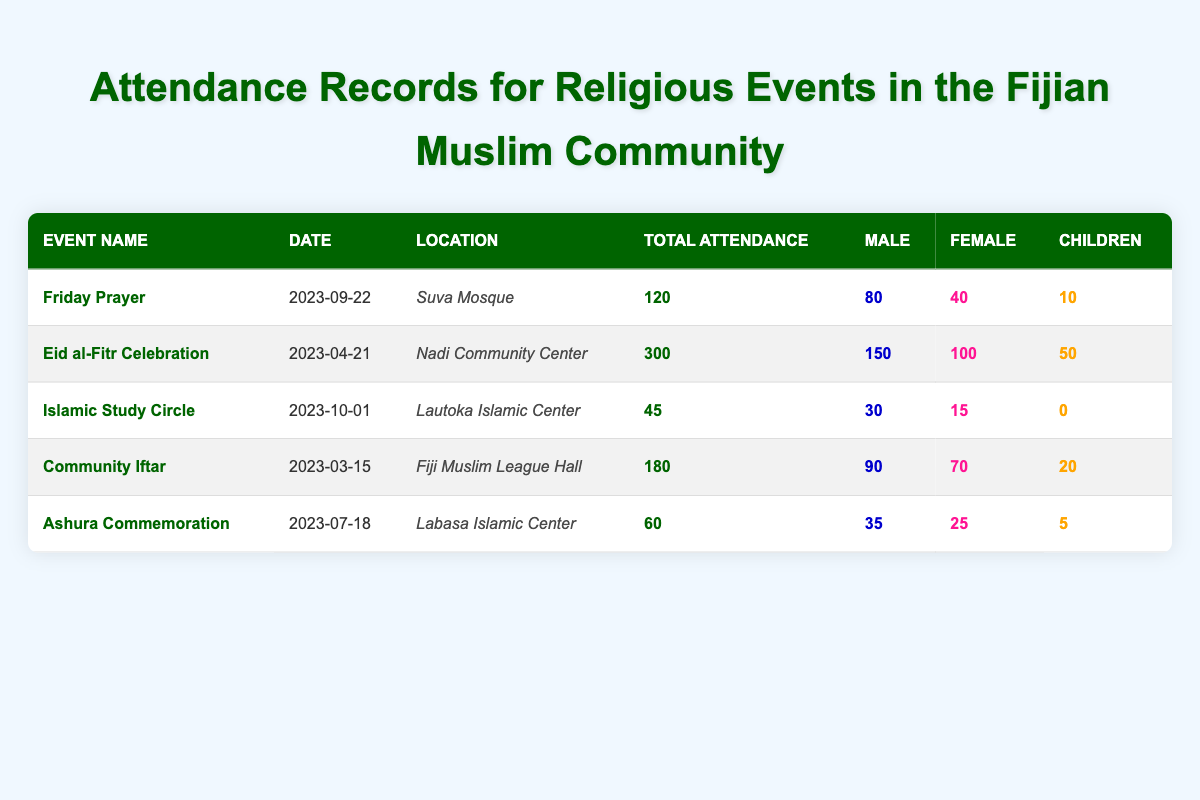What is the total attendance for the Eid al-Fitr Celebration? The table indicates that the total attendance for the Eid al-Fitr Celebration is listed under the "Total Attendance" column for that event. Referring to that entry, the total attendance is 300.
Answer: 300 How many females attended the Friday Prayer? Looking at the row for the Friday Prayer event, the table shows that the number of females in attendance is listed as 40 under the "Female" column.
Answer: 40 Was the total attendance for the Community Iftar greater than that for the Ashura Commemoration? The total attendance for the Community Iftar is 180, and for the Ashura Commemoration, it is 60. Since 180 is greater than 60, the answer is yes.
Answer: Yes What is the average number of children that attended all events? To find the average number of children, we need to add up the number of children from all events: 10 (Friday Prayer) + 50 (Eid al-Fitr) + 0 (Islamic Study Circle) + 20 (Community Iftar) + 5 (Ashura Commemoration) = 85. There are 5 events, so the average is 85/5 = 17.
Answer: 17 Which event had the highest male attendance? By checking the "Male" column for each event, we see that the Eid al-Fitr Celebration has the highest attendance with 150 male attendees compared to other events.
Answer: Eid al-Fitr Celebration How many more males attended the Community Iftar than the Islamic Study Circle? The Community Iftar had 90 males, and the Islamic Study Circle had 30 males. The difference is 90 - 30 = 60. Therefore, 60 more males attended the Community Iftar.
Answer: 60 On which date was the Islamic Study Circle held? The row for the Islamic Study Circle lists the date under the "Date" column as 2023-10-01.
Answer: 2023-10-01 Did any events have children in attendance? By reviewing the "Children" column for each event, we find that the Friday Prayer, Community Iftar, and Ashura Commemoration events all reported children, confirming that some events had children in attendance.
Answer: Yes 